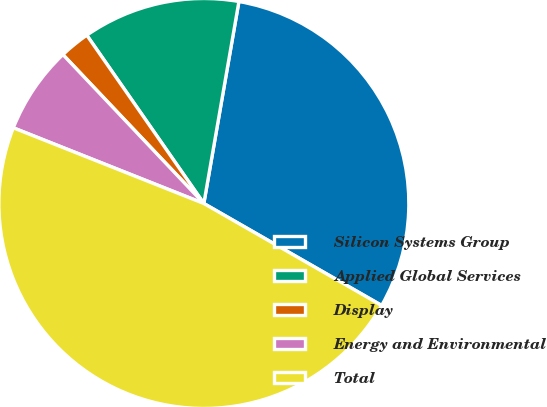Convert chart. <chart><loc_0><loc_0><loc_500><loc_500><pie_chart><fcel>Silicon Systems Group<fcel>Applied Global Services<fcel>Display<fcel>Energy and Environmental<fcel>Total<nl><fcel>30.55%<fcel>12.41%<fcel>2.39%<fcel>6.92%<fcel>47.73%<nl></chart> 